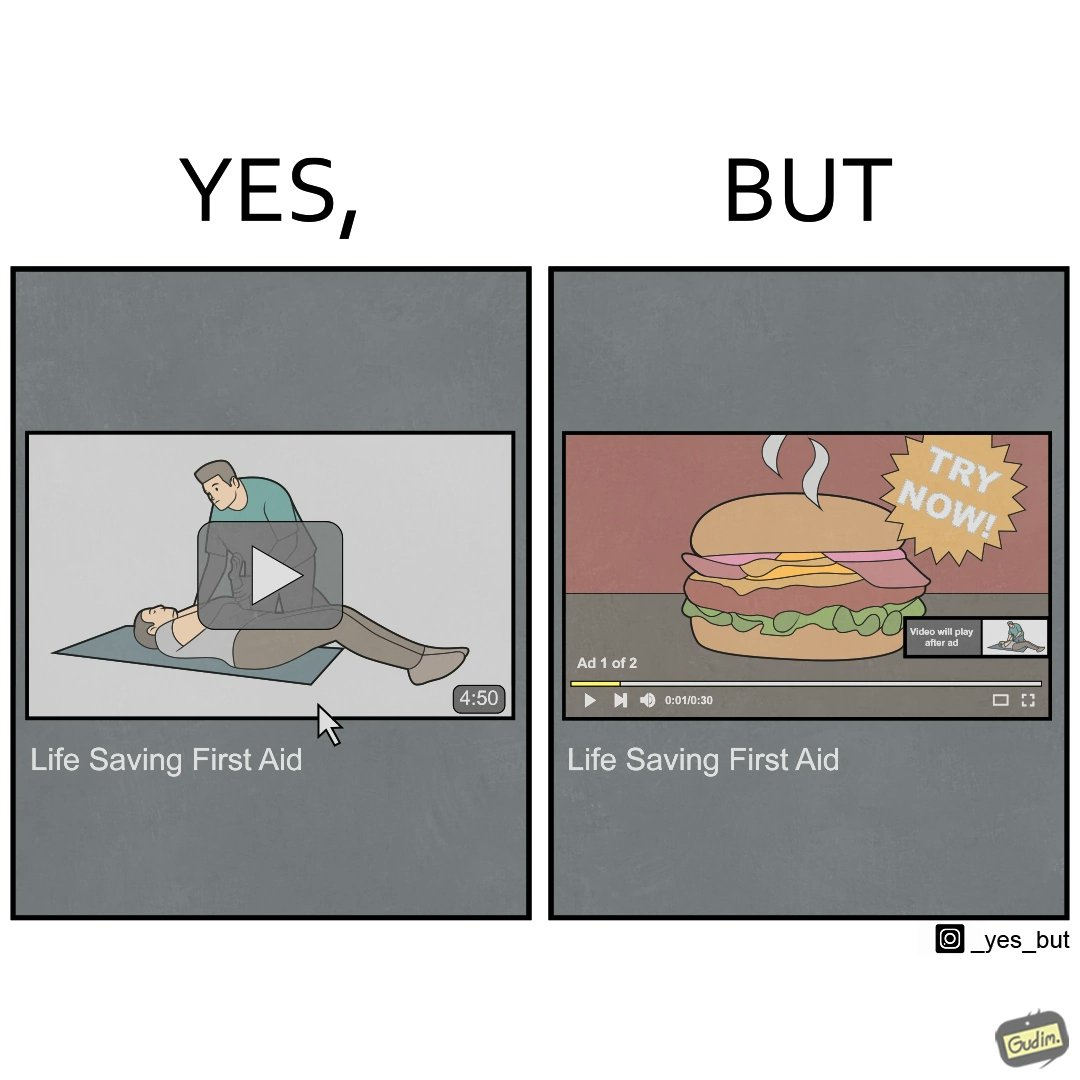Describe what you see in the left and right parts of this image. In the left part of the image: a video of 4 mins 50 secs on the internet titled "Life Saving First Aid". In the right part of the image: The first ad of 30 secs of 2 ads, showing a burger, with a sign that says "Try Now". 